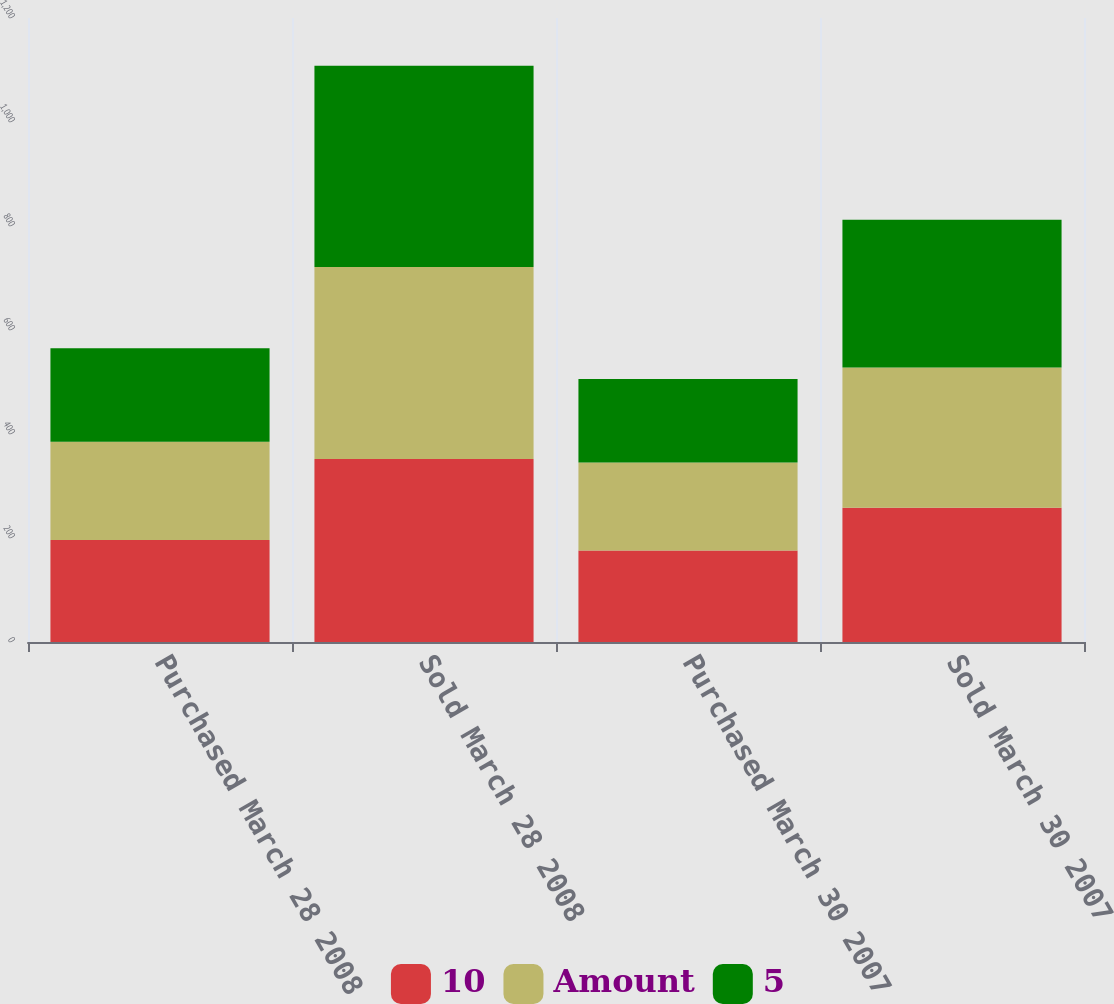Convert chart. <chart><loc_0><loc_0><loc_500><loc_500><stacked_bar_chart><ecel><fcel>Purchased March 28 2008<fcel>Sold March 28 2008<fcel>Purchased March 30 2007<fcel>Sold March 30 2007<nl><fcel>10<fcel>196<fcel>352<fcel>176<fcel>258<nl><fcel>Amount<fcel>189<fcel>369<fcel>169<fcel>270<nl><fcel>5<fcel>180<fcel>387<fcel>161<fcel>284<nl></chart> 